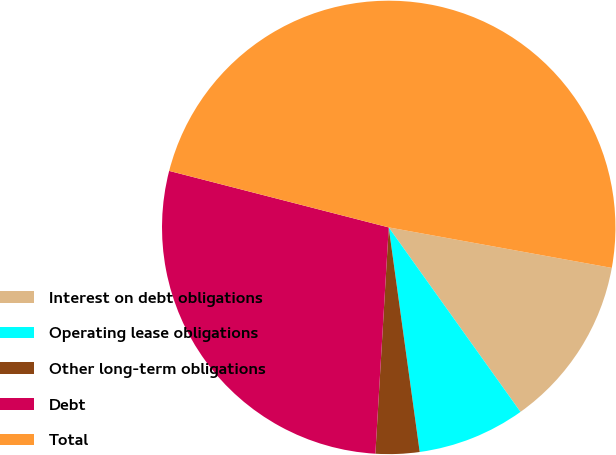Convert chart to OTSL. <chart><loc_0><loc_0><loc_500><loc_500><pie_chart><fcel>Interest on debt obligations<fcel>Operating lease obligations<fcel>Other long-term obligations<fcel>Debt<fcel>Total<nl><fcel>12.27%<fcel>7.69%<fcel>3.12%<fcel>28.07%<fcel>48.85%<nl></chart> 